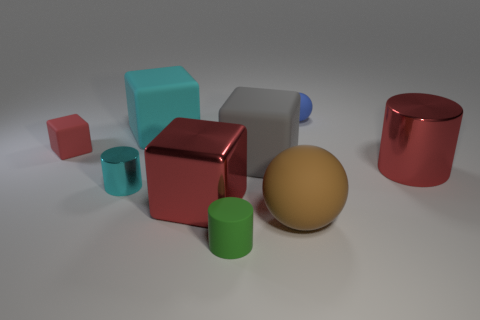There is a object that is behind the red rubber thing and to the right of the small green thing; what material is it?
Your answer should be very brief. Rubber. Are there fewer blue spheres than tiny brown metallic cylinders?
Make the answer very short. No. There is a tiny green object; is it the same shape as the thing on the right side of the blue thing?
Your answer should be very brief. Yes. There is a thing in front of the brown thing; is it the same size as the cyan cylinder?
Give a very brief answer. Yes. What is the shape of the blue thing that is the same size as the rubber cylinder?
Provide a succinct answer. Sphere. Is the small red matte object the same shape as the tiny blue thing?
Your response must be concise. No. How many gray rubber objects have the same shape as the large cyan object?
Provide a short and direct response. 1. There is a tiny red cube; how many big brown rubber objects are to the left of it?
Your answer should be compact. 0. Does the large cylinder on the right side of the big cyan block have the same color as the small cube?
Offer a terse response. Yes. How many metallic balls have the same size as the blue object?
Ensure brevity in your answer.  0. 